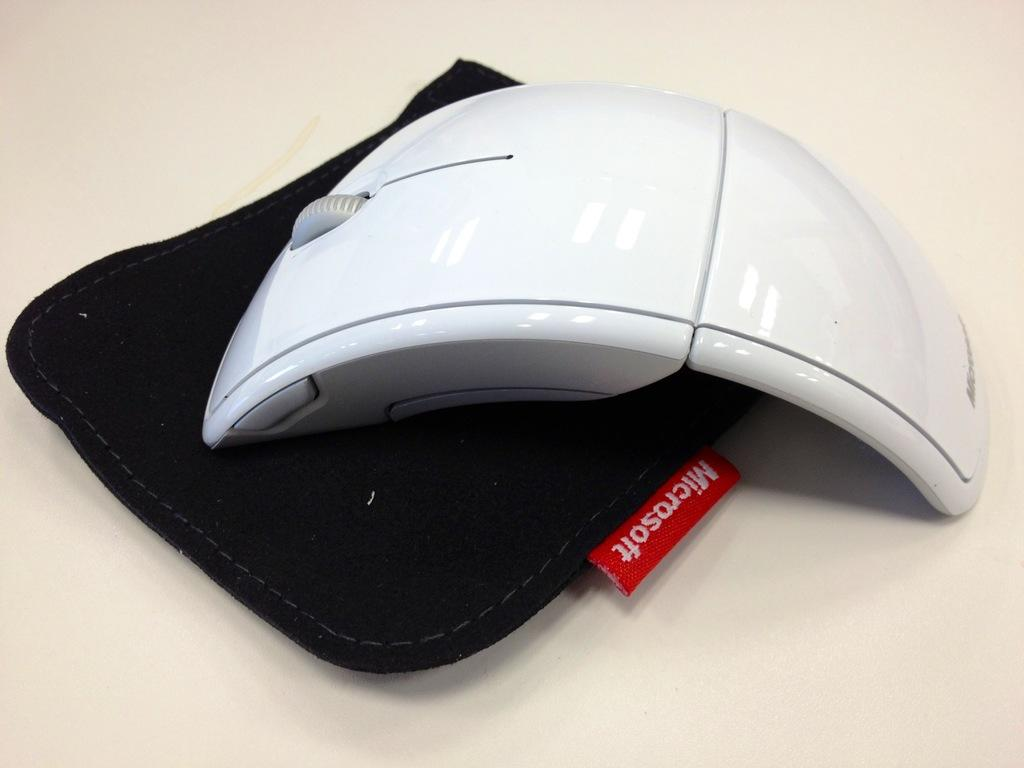What type of animal is in the image? There is a white mouse in the image. What is the mouse sitting on? The white mouse is on a black mouse pad. Is there any text or design on the mouse pad? Yes, there is a label on the mouse pad. What is the mouse pad placed on? The mouse pad is on an object. Is the white mouse reading a book in the image? No, there is no book or any indication of reading in the image. 